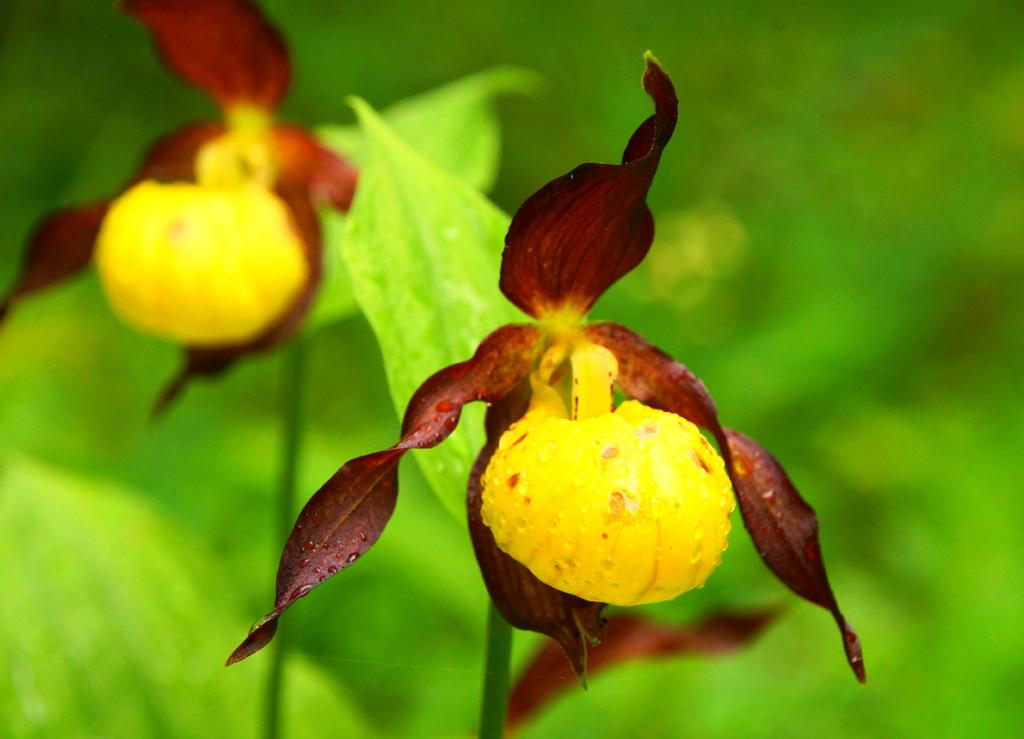How many flowers are present in the image? There are two flowers in the image. What colors can be seen on the flowers? The flowers are yellow and brown in color. Can you describe the background of the image? The background is green and blurry. What type of oatmeal is being served at the event in the image? There is no event or oatmeal present in the image; it features two flowers with a green and blurry background. 